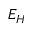Convert formula to latex. <formula><loc_0><loc_0><loc_500><loc_500>E _ { H }</formula> 